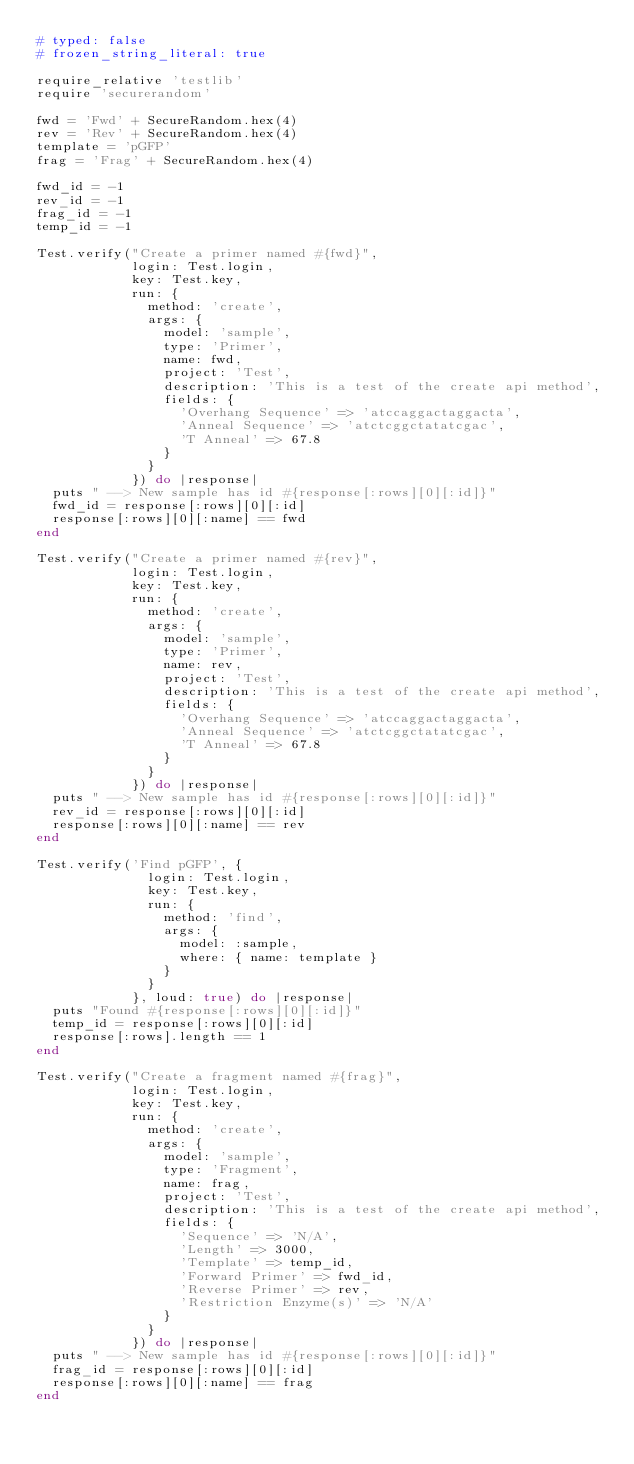Convert code to text. <code><loc_0><loc_0><loc_500><loc_500><_Ruby_># typed: false
# frozen_string_literal: true

require_relative 'testlib'
require 'securerandom'

fwd = 'Fwd' + SecureRandom.hex(4)
rev = 'Rev' + SecureRandom.hex(4)
template = 'pGFP'
frag = 'Frag' + SecureRandom.hex(4)

fwd_id = -1
rev_id = -1
frag_id = -1
temp_id = -1

Test.verify("Create a primer named #{fwd}",
            login: Test.login,
            key: Test.key,
            run: {
              method: 'create',
              args: {
                model: 'sample',
                type: 'Primer',
                name: fwd,
                project: 'Test',
                description: 'This is a test of the create api method',
                fields: {
                  'Overhang Sequence' => 'atccaggactaggacta',
                  'Anneal Sequence' => 'atctcggctatatcgac',
                  'T Anneal' => 67.8
                }
              }
            }) do |response|
  puts " --> New sample has id #{response[:rows][0][:id]}"
  fwd_id = response[:rows][0][:id]
  response[:rows][0][:name] == fwd
end

Test.verify("Create a primer named #{rev}",
            login: Test.login,
            key: Test.key,
            run: {
              method: 'create',
              args: {
                model: 'sample',
                type: 'Primer',
                name: rev,
                project: 'Test',
                description: 'This is a test of the create api method',
                fields: {
                  'Overhang Sequence' => 'atccaggactaggacta',
                  'Anneal Sequence' => 'atctcggctatatcgac',
                  'T Anneal' => 67.8
                }
              }
            }) do |response|
  puts " --> New sample has id #{response[:rows][0][:id]}"
  rev_id = response[:rows][0][:id]
  response[:rows][0][:name] == rev
end

Test.verify('Find pGFP', {
              login: Test.login,
              key: Test.key,
              run: {
                method: 'find',
                args: {
                  model: :sample,
                  where: { name: template }
                }
              }
            }, loud: true) do |response|
  puts "Found #{response[:rows][0][:id]}"
  temp_id = response[:rows][0][:id]
  response[:rows].length == 1
end

Test.verify("Create a fragment named #{frag}",
            login: Test.login,
            key: Test.key,
            run: {
              method: 'create',
              args: {
                model: 'sample',
                type: 'Fragment',
                name: frag,
                project: 'Test',
                description: 'This is a test of the create api method',
                fields: {
                  'Sequence' => 'N/A',
                  'Length' => 3000,
                  'Template' => temp_id,
                  'Forward Primer' => fwd_id,
                  'Reverse Primer' => rev,
                  'Restriction Enzyme(s)' => 'N/A'
                }
              }
            }) do |response|
  puts " --> New sample has id #{response[:rows][0][:id]}"
  frag_id = response[:rows][0][:id]
  response[:rows][0][:name] == frag
end
</code> 